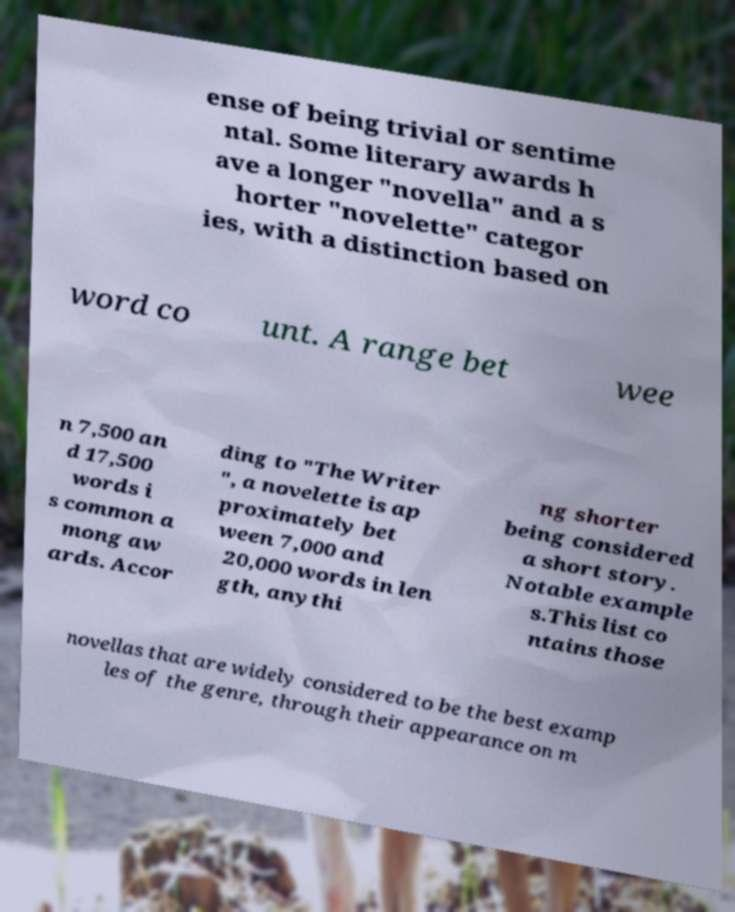Can you read and provide the text displayed in the image?This photo seems to have some interesting text. Can you extract and type it out for me? ense of being trivial or sentime ntal. Some literary awards h ave a longer "novella" and a s horter "novelette" categor ies, with a distinction based on word co unt. A range bet wee n 7,500 an d 17,500 words i s common a mong aw ards. Accor ding to "The Writer ", a novelette is ap proximately bet ween 7,000 and 20,000 words in len gth, anythi ng shorter being considered a short story. Notable example s.This list co ntains those novellas that are widely considered to be the best examp les of the genre, through their appearance on m 